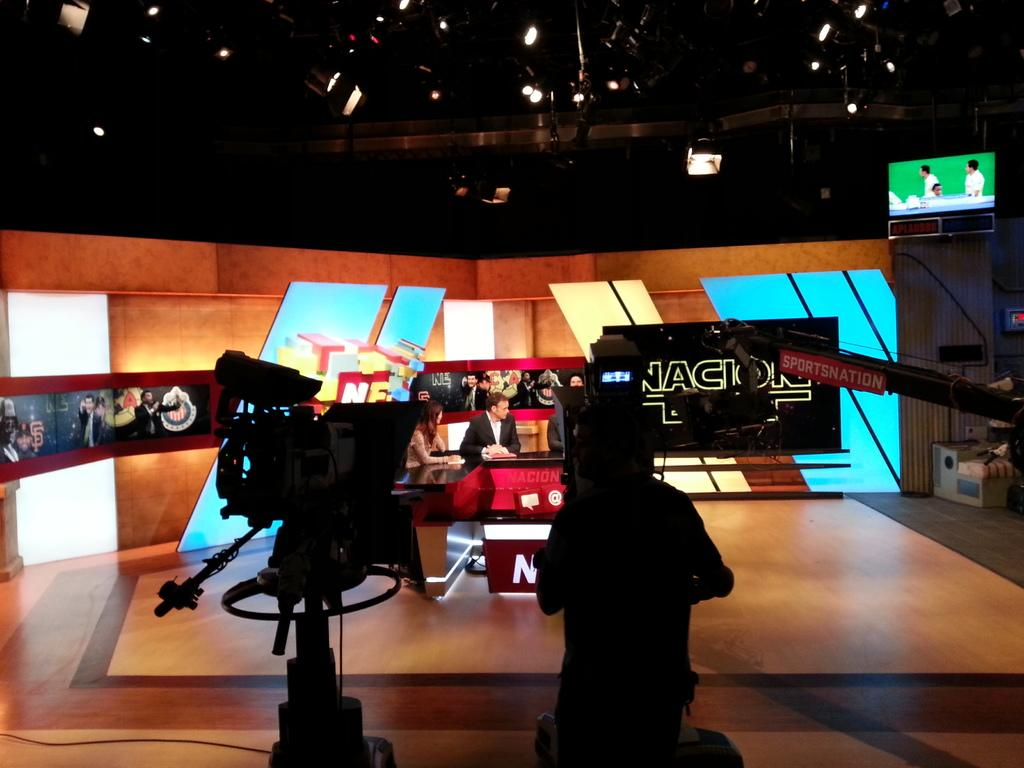Provide a one-sentence caption for the provided image. a tv studio and the letters AC on a screen. 